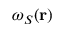<formula> <loc_0><loc_0><loc_500><loc_500>\omega _ { S } ( r )</formula> 